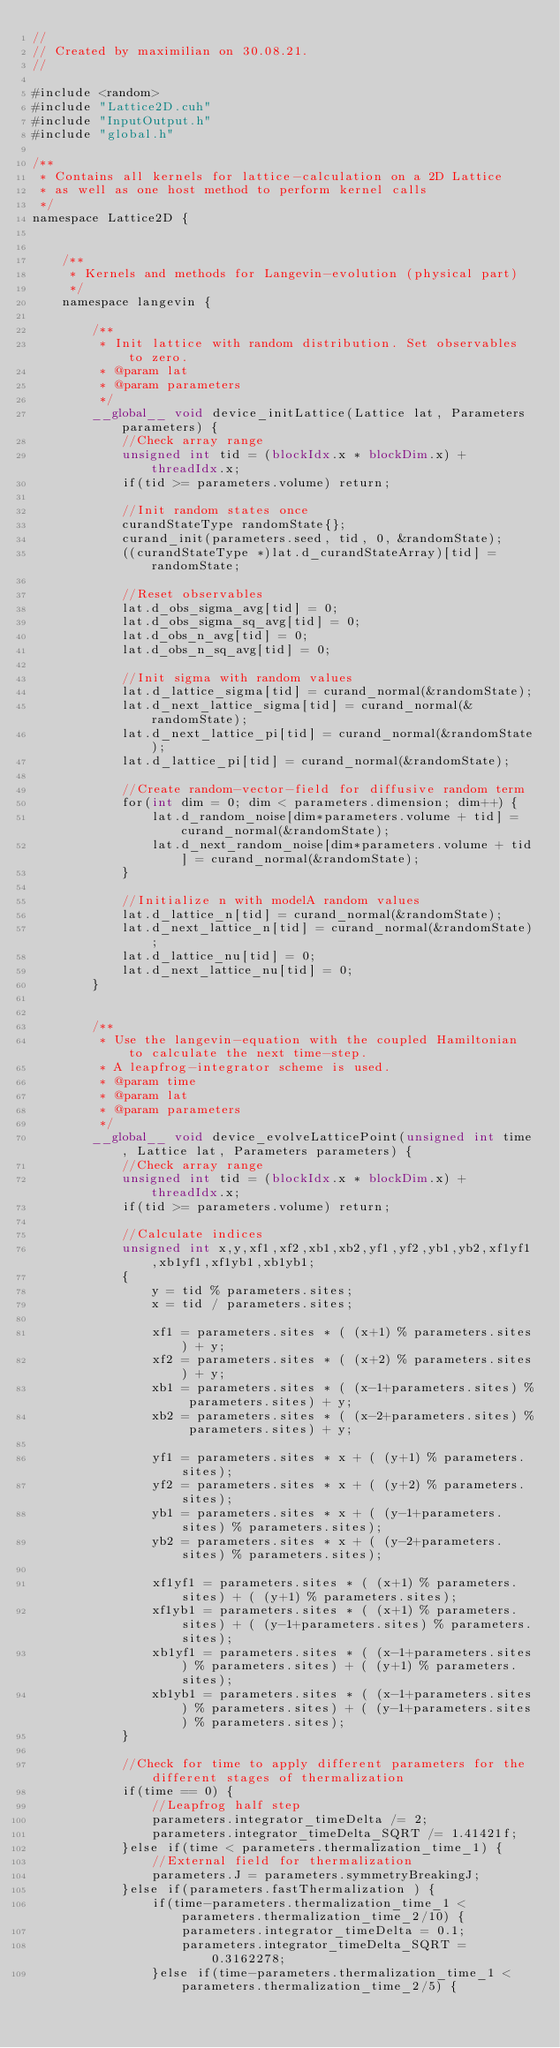<code> <loc_0><loc_0><loc_500><loc_500><_Cuda_>//
// Created by maximilian on 30.08.21.
//

#include <random>
#include "Lattice2D.cuh"
#include "InputOutput.h"
#include "global.h"

/**
 * Contains all kernels for lattice-calculation on a 2D Lattice
 * as well as one host method to perform kernel calls
 */
namespace Lattice2D {


    /**
     * Kernels and methods for Langevin-evolution (physical part)
     */
    namespace langevin {

        /**
         * Init lattice with random distribution. Set observables to zero.
         * @param lat
         * @param parameters
         */
        __global__ void device_initLattice(Lattice lat, Parameters parameters) {
            //Check array range
            unsigned int tid = (blockIdx.x * blockDim.x) + threadIdx.x;
            if(tid >= parameters.volume) return;

            //Init random states once
            curandStateType randomState{};
            curand_init(parameters.seed, tid, 0, &randomState);
            ((curandStateType *)lat.d_curandStateArray)[tid] = randomState;

            //Reset observables
            lat.d_obs_sigma_avg[tid] = 0;
            lat.d_obs_sigma_sq_avg[tid] = 0;
            lat.d_obs_n_avg[tid] = 0;
            lat.d_obs_n_sq_avg[tid] = 0;

            //Init sigma with random values
            lat.d_lattice_sigma[tid] = curand_normal(&randomState);
            lat.d_next_lattice_sigma[tid] = curand_normal(&randomState);
            lat.d_next_lattice_pi[tid] = curand_normal(&randomState);
            lat.d_lattice_pi[tid] = curand_normal(&randomState);

            //Create random-vector-field for diffusive random term
            for(int dim = 0; dim < parameters.dimension; dim++) {
                lat.d_random_noise[dim*parameters.volume + tid] = curand_normal(&randomState);
                lat.d_next_random_noise[dim*parameters.volume + tid] = curand_normal(&randomState);
            }

            //Initialize n with modelA random values
            lat.d_lattice_n[tid] = curand_normal(&randomState);
            lat.d_next_lattice_n[tid] = curand_normal(&randomState);
            lat.d_lattice_nu[tid] = 0;
            lat.d_next_lattice_nu[tid] = 0;
        }


        /**
         * Use the langevin-equation with the coupled Hamiltonian to calculate the next time-step.
         * A leapfrog-integrator scheme is used.
         * @param time
         * @param lat
         * @param parameters
         */
        __global__ void device_evolveLatticePoint(unsigned int time, Lattice lat, Parameters parameters) {
            //Check array range
            unsigned int tid = (blockIdx.x * blockDim.x) + threadIdx.x;
            if(tid >= parameters.volume) return;

            //Calculate indices
            unsigned int x,y,xf1,xf2,xb1,xb2,yf1,yf2,yb1,yb2,xf1yf1,xb1yf1,xf1yb1,xb1yb1;
            {
                y = tid % parameters.sites;
                x = tid / parameters.sites;

                xf1 = parameters.sites * ( (x+1) % parameters.sites) + y;
                xf2 = parameters.sites * ( (x+2) % parameters.sites) + y;
                xb1 = parameters.sites * ( (x-1+parameters.sites) % parameters.sites) + y;
                xb2 = parameters.sites * ( (x-2+parameters.sites) % parameters.sites) + y;

                yf1 = parameters.sites * x + ( (y+1) % parameters.sites);
                yf2 = parameters.sites * x + ( (y+2) % parameters.sites);
                yb1 = parameters.sites * x + ( (y-1+parameters.sites) % parameters.sites);
                yb2 = parameters.sites * x + ( (y-2+parameters.sites) % parameters.sites);

                xf1yf1 = parameters.sites * ( (x+1) % parameters.sites) + ( (y+1) % parameters.sites);
                xf1yb1 = parameters.sites * ( (x+1) % parameters.sites) + ( (y-1+parameters.sites) % parameters.sites);
                xb1yf1 = parameters.sites * ( (x-1+parameters.sites) % parameters.sites) + ( (y+1) % parameters.sites);
                xb1yb1 = parameters.sites * ( (x-1+parameters.sites) % parameters.sites) + ( (y-1+parameters.sites) % parameters.sites);
            }

            //Check for time to apply different parameters for the different stages of thermalization
            if(time == 0) {
                //Leapfrog half step
                parameters.integrator_timeDelta /= 2;
                parameters.integrator_timeDelta_SQRT /= 1.41421f;
            }else if(time < parameters.thermalization_time_1) {
                //External field for thermalization
                parameters.J = parameters.symmetryBreakingJ;
            }else if(parameters.fastThermalization ) {
                if(time-parameters.thermalization_time_1 < parameters.thermalization_time_2/10) {
                    parameters.integrator_timeDelta = 0.1;
                    parameters.integrator_timeDelta_SQRT = 0.3162278;
                }else if(time-parameters.thermalization_time_1 < parameters.thermalization_time_2/5) {</code> 